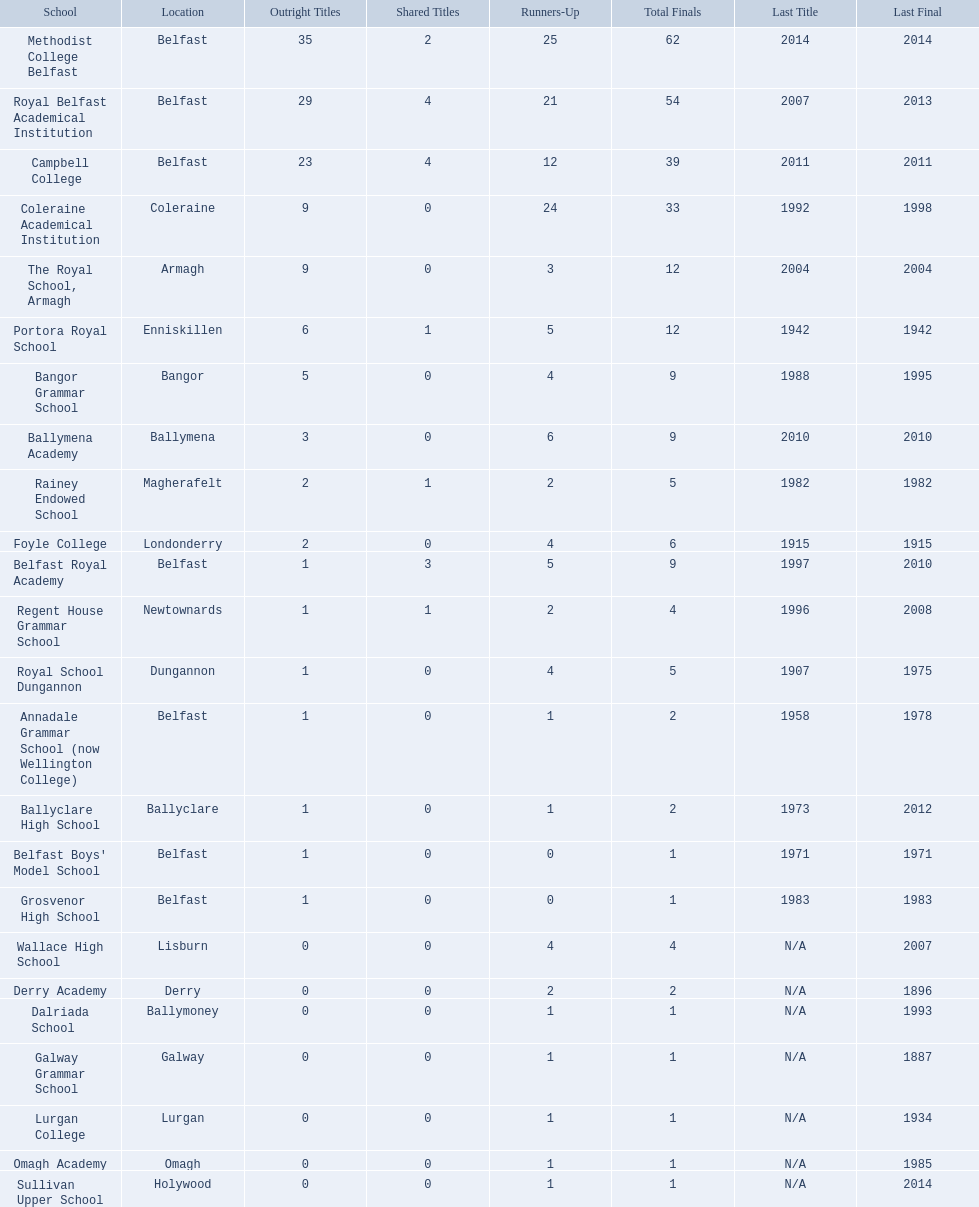Could you parse the entire table? {'header': ['School', 'Location', 'Outright Titles', 'Shared Titles', 'Runners-Up', 'Total Finals', 'Last Title', 'Last Final'], 'rows': [['Methodist College Belfast', 'Belfast', '35', '2', '25', '62', '2014', '2014'], ['Royal Belfast Academical Institution', 'Belfast', '29', '4', '21', '54', '2007', '2013'], ['Campbell College', 'Belfast', '23', '4', '12', '39', '2011', '2011'], ['Coleraine Academical Institution', 'Coleraine', '9', '0', '24', '33', '1992', '1998'], ['The Royal School, Armagh', 'Armagh', '9', '0', '3', '12', '2004', '2004'], ['Portora Royal School', 'Enniskillen', '6', '1', '5', '12', '1942', '1942'], ['Bangor Grammar School', 'Bangor', '5', '0', '4', '9', '1988', '1995'], ['Ballymena Academy', 'Ballymena', '3', '0', '6', '9', '2010', '2010'], ['Rainey Endowed School', 'Magherafelt', '2', '1', '2', '5', '1982', '1982'], ['Foyle College', 'Londonderry', '2', '0', '4', '6', '1915', '1915'], ['Belfast Royal Academy', 'Belfast', '1', '3', '5', '9', '1997', '2010'], ['Regent House Grammar School', 'Newtownards', '1', '1', '2', '4', '1996', '2008'], ['Royal School Dungannon', 'Dungannon', '1', '0', '4', '5', '1907', '1975'], ['Annadale Grammar School (now Wellington College)', 'Belfast', '1', '0', '1', '2', '1958', '1978'], ['Ballyclare High School', 'Ballyclare', '1', '0', '1', '2', '1973', '2012'], ["Belfast Boys' Model School", 'Belfast', '1', '0', '0', '1', '1971', '1971'], ['Grosvenor High School', 'Belfast', '1', '0', '0', '1', '1983', '1983'], ['Wallace High School', 'Lisburn', '0', '0', '4', '4', 'N/A', '2007'], ['Derry Academy', 'Derry', '0', '0', '2', '2', 'N/A', '1896'], ['Dalriada School', 'Ballymoney', '0', '0', '1', '1', 'N/A', '1993'], ['Galway Grammar School', 'Galway', '0', '0', '1', '1', 'N/A', '1887'], ['Lurgan College', 'Lurgan', '0', '0', '1', '1', 'N/A', '1934'], ['Omagh Academy', 'Omagh', '0', '0', '1', '1', 'N/A', '1985'], ['Sullivan Upper School', 'Holywood', '0', '0', '1', '1', 'N/A', '2014']]} How many total titles does coleraine academical institution hold? 9. What other academic institution has this number of total titles? The Royal School, Armagh. 